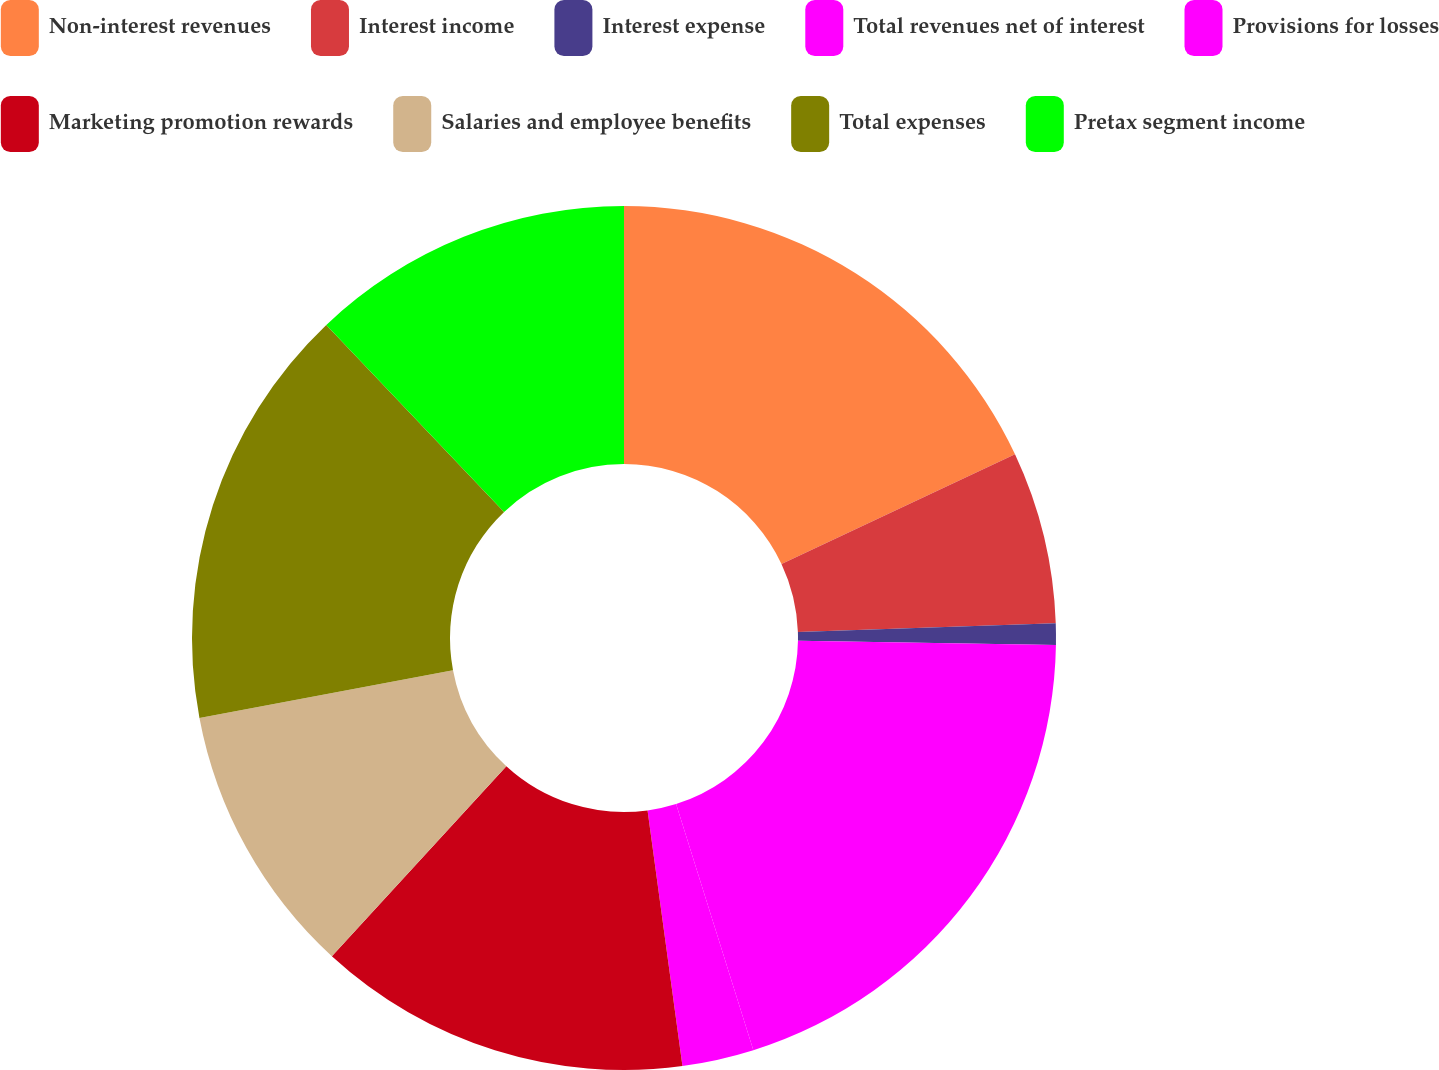Convert chart to OTSL. <chart><loc_0><loc_0><loc_500><loc_500><pie_chart><fcel>Non-interest revenues<fcel>Interest income<fcel>Interest expense<fcel>Total revenues net of interest<fcel>Provisions for losses<fcel>Marketing promotion rewards<fcel>Salaries and employee benefits<fcel>Total expenses<fcel>Pretax segment income<nl><fcel>18.01%<fcel>6.45%<fcel>0.8%<fcel>19.9%<fcel>2.68%<fcel>13.98%<fcel>10.22%<fcel>15.86%<fcel>12.1%<nl></chart> 